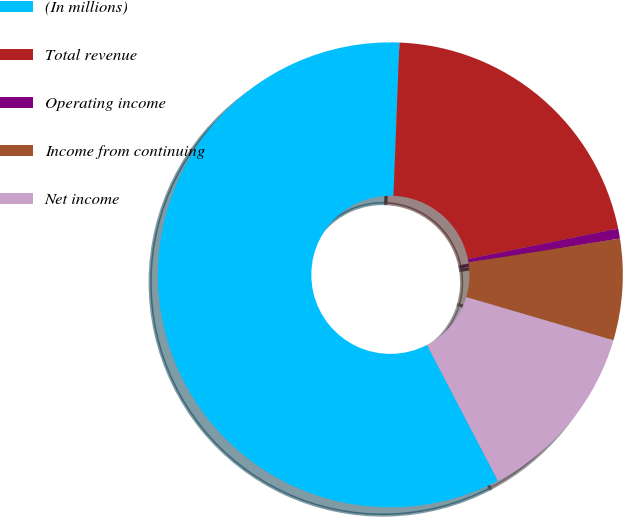Convert chart to OTSL. <chart><loc_0><loc_0><loc_500><loc_500><pie_chart><fcel>(In millions)<fcel>Total revenue<fcel>Operating income<fcel>Income from continuing<fcel>Net income<nl><fcel>58.28%<fcel>21.19%<fcel>0.69%<fcel>7.04%<fcel>12.79%<nl></chart> 